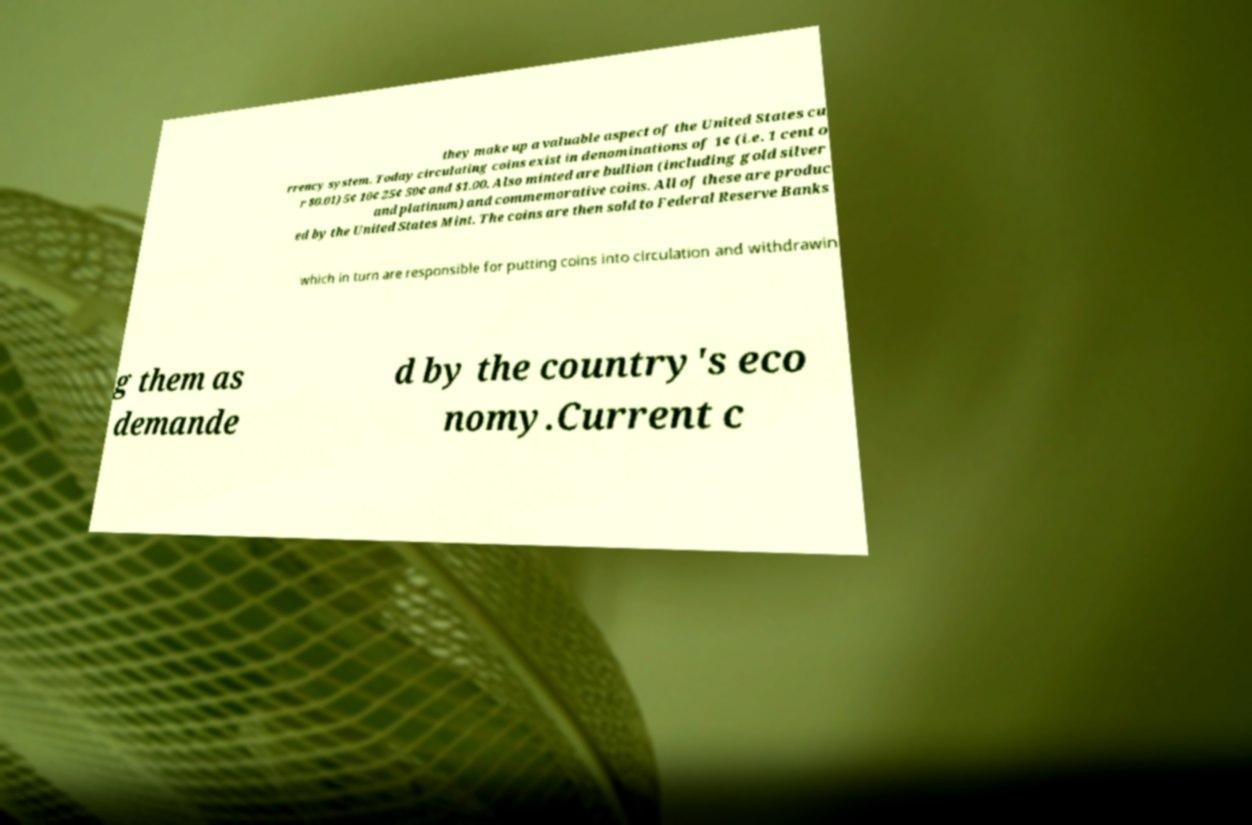Could you assist in decoding the text presented in this image and type it out clearly? they make up a valuable aspect of the United States cu rrency system. Today circulating coins exist in denominations of 1¢ (i.e. 1 cent o r $0.01) 5¢ 10¢ 25¢ 50¢ and $1.00. Also minted are bullion (including gold silver and platinum) and commemorative coins. All of these are produc ed by the United States Mint. The coins are then sold to Federal Reserve Banks which in turn are responsible for putting coins into circulation and withdrawin g them as demande d by the country's eco nomy.Current c 